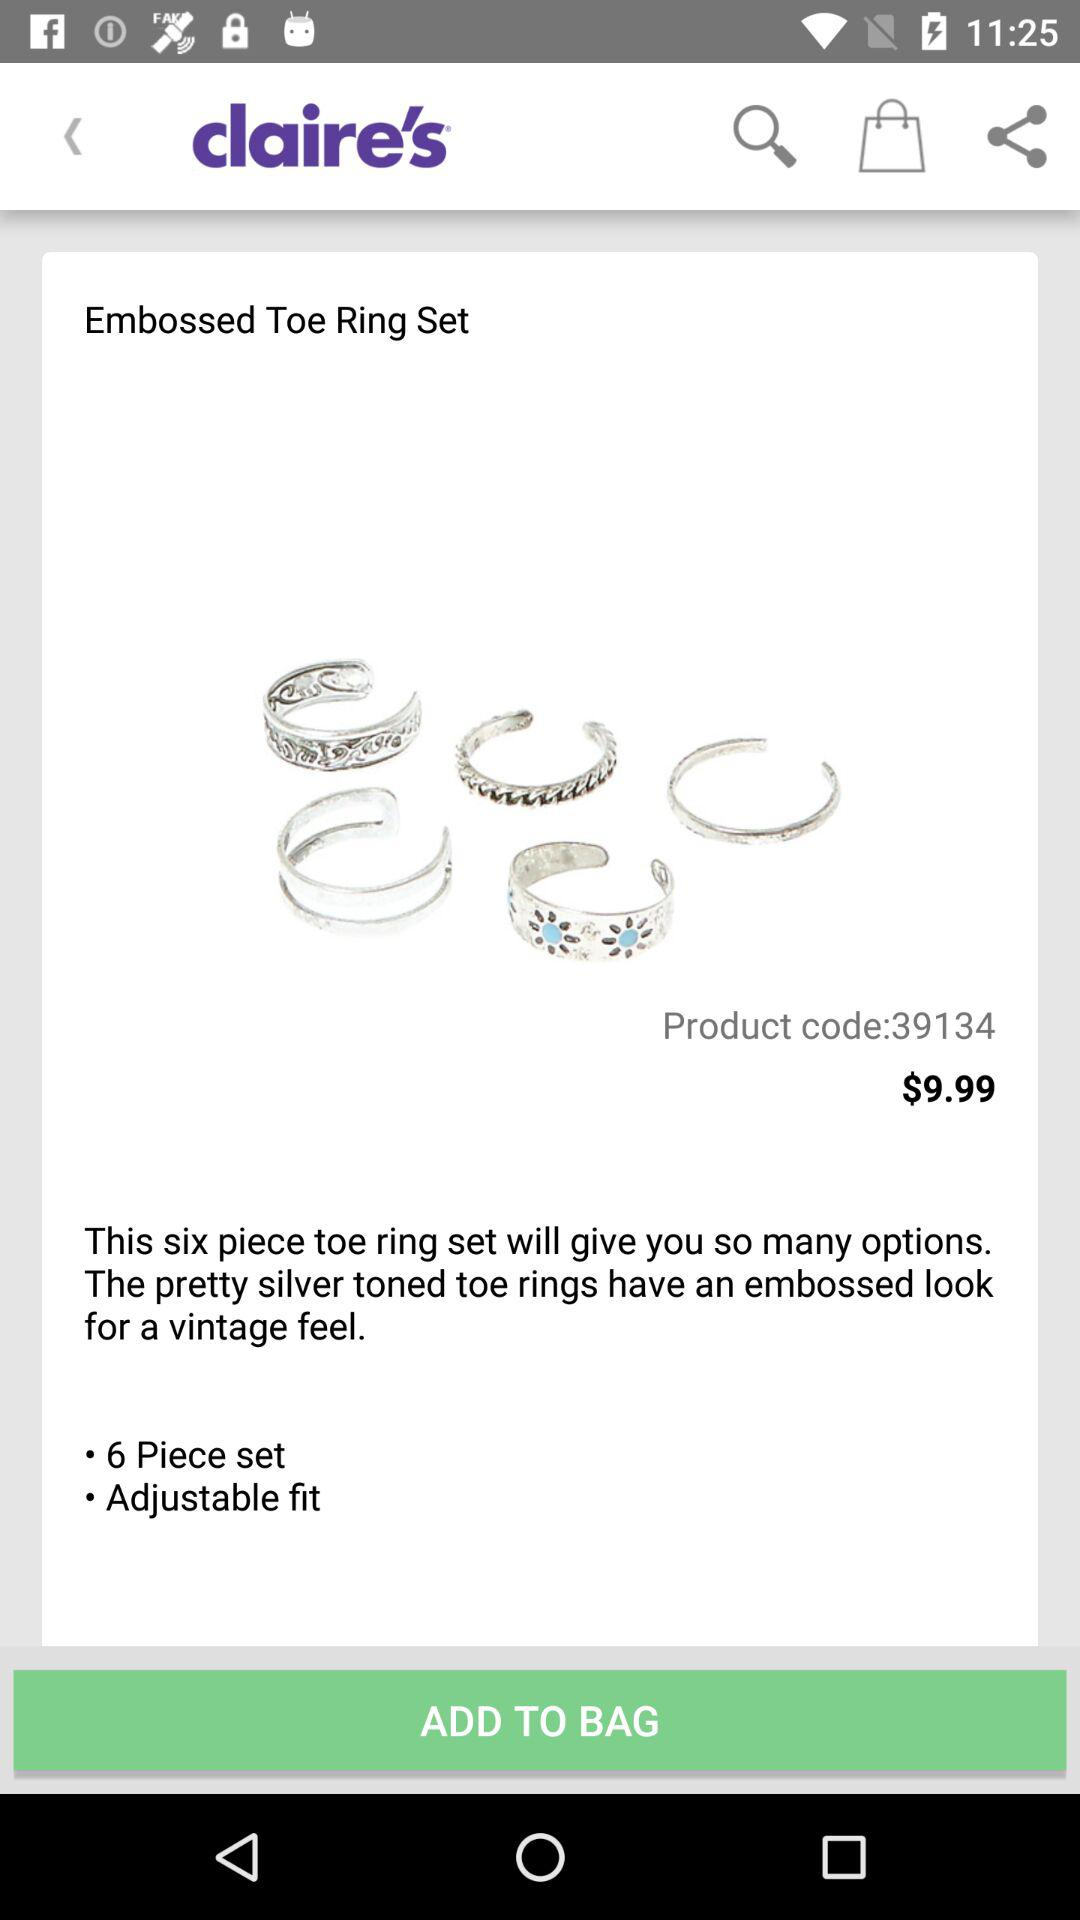How is the fit? The fit is adjustable. 